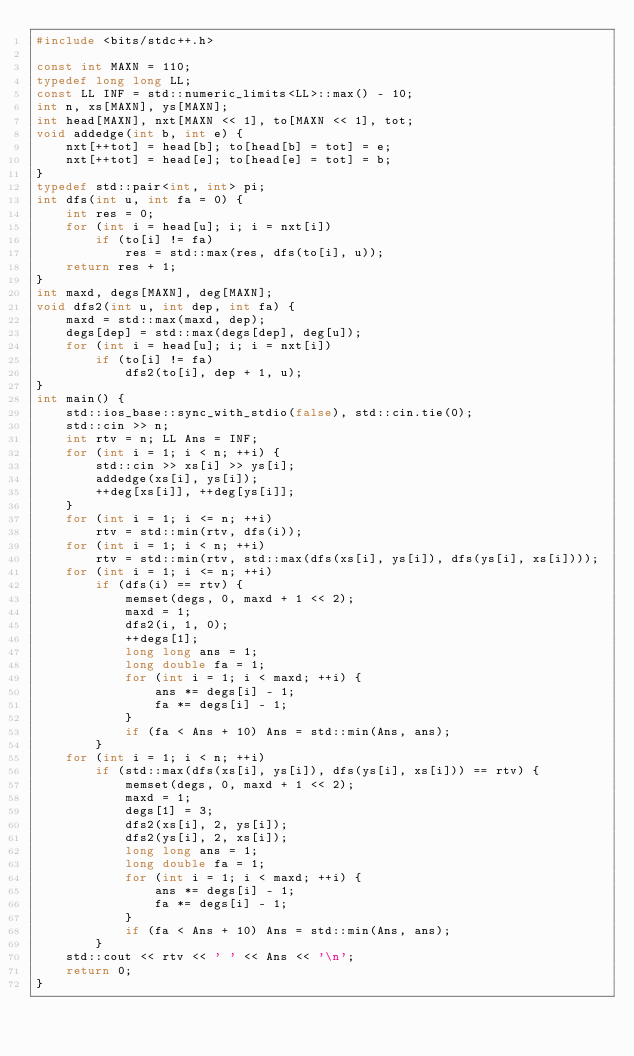<code> <loc_0><loc_0><loc_500><loc_500><_C++_>#include <bits/stdc++.h>

const int MAXN = 110;
typedef long long LL;
const LL INF = std::numeric_limits<LL>::max() - 10;
int n, xs[MAXN], ys[MAXN];
int head[MAXN], nxt[MAXN << 1], to[MAXN << 1], tot;
void addedge(int b, int e) {
	nxt[++tot] = head[b]; to[head[b] = tot] = e;
	nxt[++tot] = head[e]; to[head[e] = tot] = b;
}
typedef std::pair<int, int> pi;
int dfs(int u, int fa = 0) {
	int res = 0;
	for (int i = head[u]; i; i = nxt[i])
		if (to[i] != fa)
			res = std::max(res, dfs(to[i], u));
	return res + 1;
}
int maxd, degs[MAXN], deg[MAXN];
void dfs2(int u, int dep, int fa) {
	maxd = std::max(maxd, dep);
	degs[dep] = std::max(degs[dep], deg[u]);
	for (int i = head[u]; i; i = nxt[i])
		if (to[i] != fa)
			dfs2(to[i], dep + 1, u);
}
int main() {
	std::ios_base::sync_with_stdio(false), std::cin.tie(0);
	std::cin >> n;
	int rtv = n; LL Ans = INF;
	for (int i = 1; i < n; ++i) {
		std::cin >> xs[i] >> ys[i];
		addedge(xs[i], ys[i]);
		++deg[xs[i]], ++deg[ys[i]];
	}
	for (int i = 1; i <= n; ++i)
		rtv = std::min(rtv, dfs(i));
	for (int i = 1; i < n; ++i)
		rtv = std::min(rtv, std::max(dfs(xs[i], ys[i]), dfs(ys[i], xs[i])));
	for (int i = 1; i <= n; ++i)
		if (dfs(i) == rtv) {
			memset(degs, 0, maxd + 1 << 2);
			maxd = 1;
			dfs2(i, 1, 0);
			++degs[1];
			long long ans = 1;
			long double fa = 1;
			for (int i = 1; i < maxd; ++i) {
				ans *= degs[i] - 1;
				fa *= degs[i] - 1;
			}
			if (fa < Ans + 10) Ans = std::min(Ans, ans);
		}
	for (int i = 1; i < n; ++i)
		if (std::max(dfs(xs[i], ys[i]), dfs(ys[i], xs[i])) == rtv) {
			memset(degs, 0, maxd + 1 << 2);
			maxd = 1;
			degs[1] = 3;
			dfs2(xs[i], 2, ys[i]);
			dfs2(ys[i], 2, xs[i]);
			long long ans = 1;
			long double fa = 1;
			for (int i = 1; i < maxd; ++i) {
				ans *= degs[i] - 1;
				fa *= degs[i] - 1;
			}
			if (fa < Ans + 10) Ans = std::min(Ans, ans);
		}
	std::cout << rtv << ' ' << Ans << '\n';
	return 0;
}
</code> 